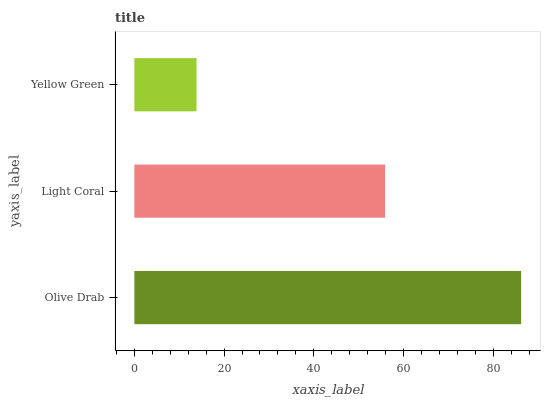Is Yellow Green the minimum?
Answer yes or no. Yes. Is Olive Drab the maximum?
Answer yes or no. Yes. Is Light Coral the minimum?
Answer yes or no. No. Is Light Coral the maximum?
Answer yes or no. No. Is Olive Drab greater than Light Coral?
Answer yes or no. Yes. Is Light Coral less than Olive Drab?
Answer yes or no. Yes. Is Light Coral greater than Olive Drab?
Answer yes or no. No. Is Olive Drab less than Light Coral?
Answer yes or no. No. Is Light Coral the high median?
Answer yes or no. Yes. Is Light Coral the low median?
Answer yes or no. Yes. Is Olive Drab the high median?
Answer yes or no. No. Is Yellow Green the low median?
Answer yes or no. No. 